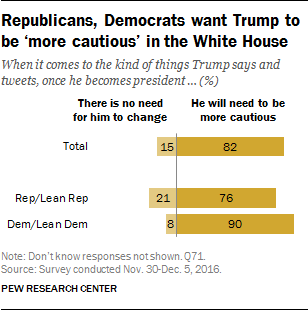List a handful of essential elements in this visual. The survey data represented in the chart belong to the leader identified as Trump. The response "he will need to be more cautious" was given by 82% of the Lean Rep group. 